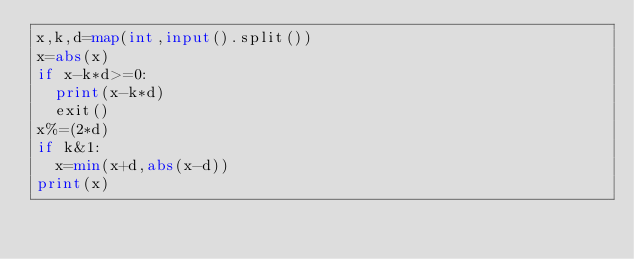<code> <loc_0><loc_0><loc_500><loc_500><_Python_>x,k,d=map(int,input().split())
x=abs(x)
if x-k*d>=0:
  print(x-k*d)
  exit()
x%=(2*d)
if k&1:
  x=min(x+d,abs(x-d))
print(x)</code> 